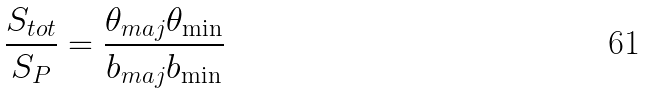<formula> <loc_0><loc_0><loc_500><loc_500>\frac { S _ { t o t } } { S _ { P } } = \frac { \theta _ { m a j } \theta _ { \min } } { b _ { m a j } b _ { \min } }</formula> 